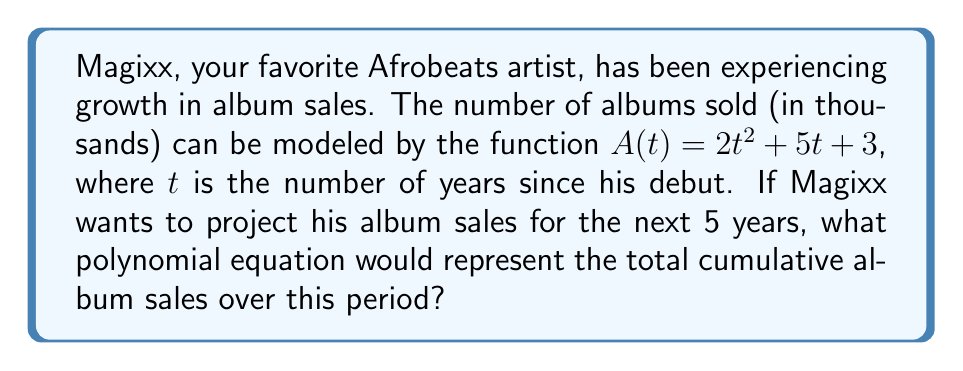Help me with this question. To find the total cumulative album sales over the next 5 years, we need to integrate the given function $A(t)$ from $t=0$ to $t=5$. Here's how we do it:

1) The given function is $A(t) = 2t^2 + 5t + 3$

2) To find the cumulative sales, we integrate this function:
   $$\int_0^5 (2t^2 + 5t + 3) dt$$

3) Integrate each term:
   $$\left[\frac{2t^3}{3} + \frac{5t^2}{2} + 3t\right]_0^5$$

4) Evaluate at the upper and lower bounds:
   $$\left(\frac{2(5^3)}{3} + \frac{5(5^2)}{2} + 3(5)\right) - \left(\frac{2(0^3)}{3} + \frac{5(0^2)}{2} + 3(0)\right)$$

5) Simplify:
   $$\left(\frac{250}{3} + \frac{125}{2} + 15\right) - 0$$

6) Convert to a common denominator:
   $$\frac{500}{6} + \frac{375}{6} + \frac{90}{6} = \frac{965}{6}$$

7) This gives us the total number of albums sold over 5 years. To express this as a polynomial in terms of $t$, we replace 5 with $t$ in our integrated function:

   $$C(t) = \frac{2t^3}{3} + \frac{5t^2}{2} + 3t$$

This polynomial $C(t)$ represents the cumulative album sales over $t$ years.
Answer: $C(t) = \frac{2t^3}{3} + \frac{5t^2}{2} + 3t$ 